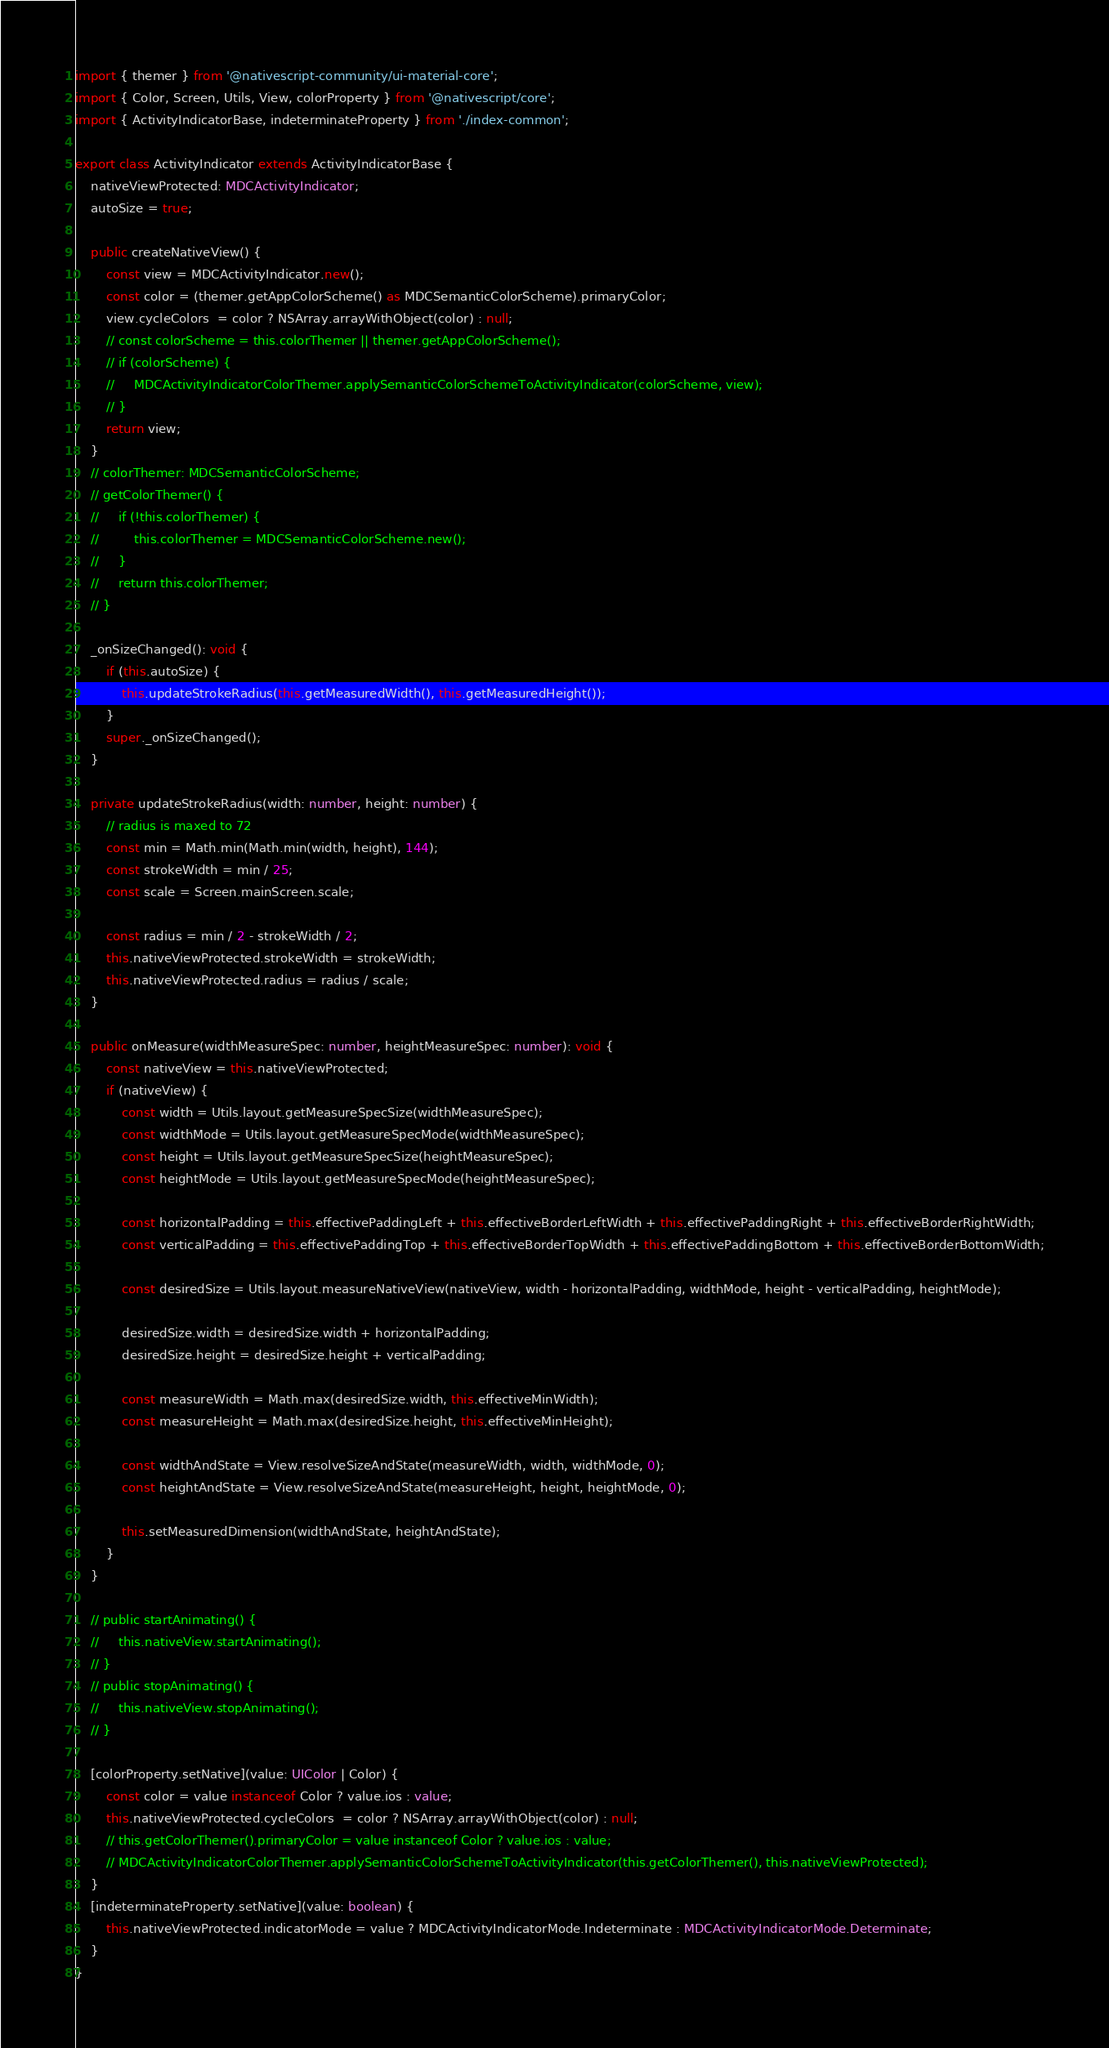Convert code to text. <code><loc_0><loc_0><loc_500><loc_500><_TypeScript_>import { themer } from '@nativescript-community/ui-material-core';
import { Color, Screen, Utils, View, colorProperty } from '@nativescript/core';
import { ActivityIndicatorBase, indeterminateProperty } from './index-common';

export class ActivityIndicator extends ActivityIndicatorBase {
    nativeViewProtected: MDCActivityIndicator;
    autoSize = true;

    public createNativeView() {
        const view = MDCActivityIndicator.new();
        const color = (themer.getAppColorScheme() as MDCSemanticColorScheme).primaryColor;
        view.cycleColors  = color ? NSArray.arrayWithObject(color) : null;
        // const colorScheme = this.colorThemer || themer.getAppColorScheme();
        // if (colorScheme) {
        //     MDCActivityIndicatorColorThemer.applySemanticColorSchemeToActivityIndicator(colorScheme, view);
        // }
        return view;
    }
    // colorThemer: MDCSemanticColorScheme;
    // getColorThemer() {
    //     if (!this.colorThemer) {
    //         this.colorThemer = MDCSemanticColorScheme.new();
    //     }
    //     return this.colorThemer;
    // }

    _onSizeChanged(): void {
        if (this.autoSize) {
            this.updateStrokeRadius(this.getMeasuredWidth(), this.getMeasuredHeight());
        }
        super._onSizeChanged();
    }

    private updateStrokeRadius(width: number, height: number) {
        // radius is maxed to 72
        const min = Math.min(Math.min(width, height), 144);
        const strokeWidth = min / 25;
        const scale = Screen.mainScreen.scale;

        const radius = min / 2 - strokeWidth / 2;
        this.nativeViewProtected.strokeWidth = strokeWidth;
        this.nativeViewProtected.radius = radius / scale;
    }

    public onMeasure(widthMeasureSpec: number, heightMeasureSpec: number): void {
        const nativeView = this.nativeViewProtected;
        if (nativeView) {
            const width = Utils.layout.getMeasureSpecSize(widthMeasureSpec);
            const widthMode = Utils.layout.getMeasureSpecMode(widthMeasureSpec);
            const height = Utils.layout.getMeasureSpecSize(heightMeasureSpec);
            const heightMode = Utils.layout.getMeasureSpecMode(heightMeasureSpec);

            const horizontalPadding = this.effectivePaddingLeft + this.effectiveBorderLeftWidth + this.effectivePaddingRight + this.effectiveBorderRightWidth;
            const verticalPadding = this.effectivePaddingTop + this.effectiveBorderTopWidth + this.effectivePaddingBottom + this.effectiveBorderBottomWidth;

            const desiredSize = Utils.layout.measureNativeView(nativeView, width - horizontalPadding, widthMode, height - verticalPadding, heightMode);

            desiredSize.width = desiredSize.width + horizontalPadding;
            desiredSize.height = desiredSize.height + verticalPadding;

            const measureWidth = Math.max(desiredSize.width, this.effectiveMinWidth);
            const measureHeight = Math.max(desiredSize.height, this.effectiveMinHeight);

            const widthAndState = View.resolveSizeAndState(measureWidth, width, widthMode, 0);
            const heightAndState = View.resolveSizeAndState(measureHeight, height, heightMode, 0);

            this.setMeasuredDimension(widthAndState, heightAndState);
        }
    }

    // public startAnimating() {
    //     this.nativeView.startAnimating();
    // }
    // public stopAnimating() {
    //     this.nativeView.stopAnimating();
    // }

    [colorProperty.setNative](value: UIColor | Color) {
        const color = value instanceof Color ? value.ios : value;
        this.nativeViewProtected.cycleColors  = color ? NSArray.arrayWithObject(color) : null;
        // this.getColorThemer().primaryColor = value instanceof Color ? value.ios : value;
        // MDCActivityIndicatorColorThemer.applySemanticColorSchemeToActivityIndicator(this.getColorThemer(), this.nativeViewProtected);
    }
    [indeterminateProperty.setNative](value: boolean) {
        this.nativeViewProtected.indicatorMode = value ? MDCActivityIndicatorMode.Indeterminate : MDCActivityIndicatorMode.Determinate;
    }
}
</code> 